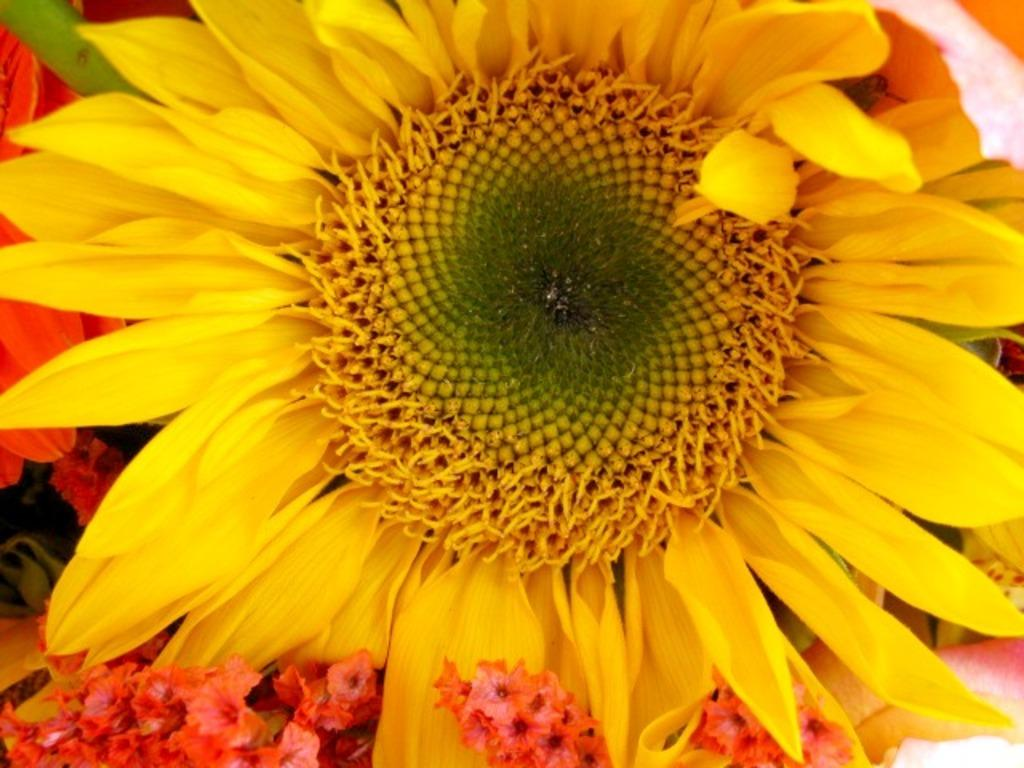What type of flower is the main subject of the image? There is a sunflower in the image. What other flowers can be seen in the image? There are red color flowers at the bottom of the image. What is the position of the sunflower in relation to the red flowers in the image? There is no information about the position of the sunflower in relation to the red flowers in the image. 